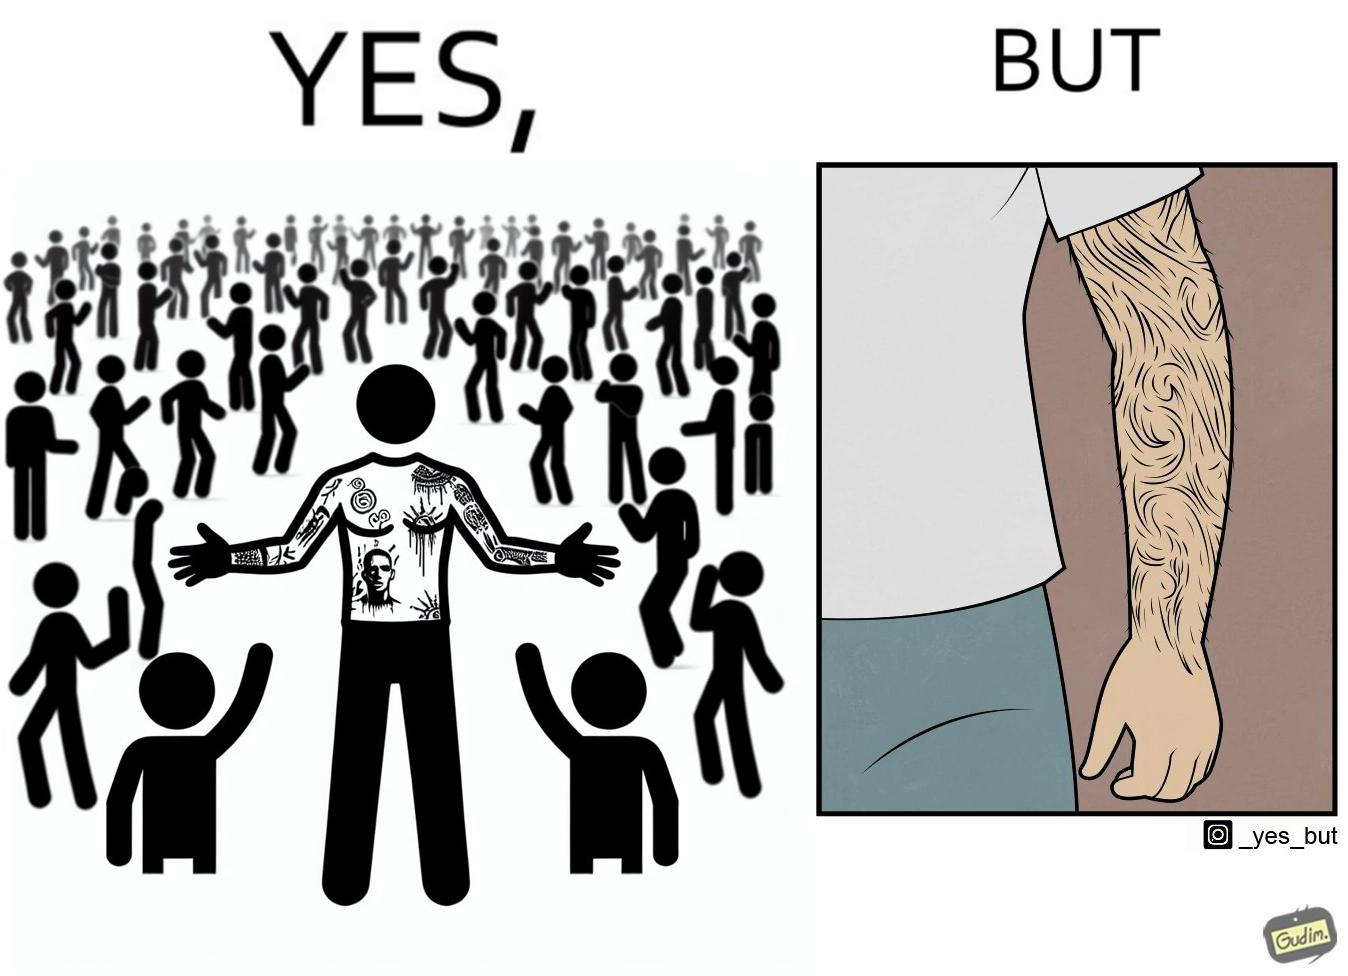Would you classify this image as satirical? Yes, this image is satirical. 